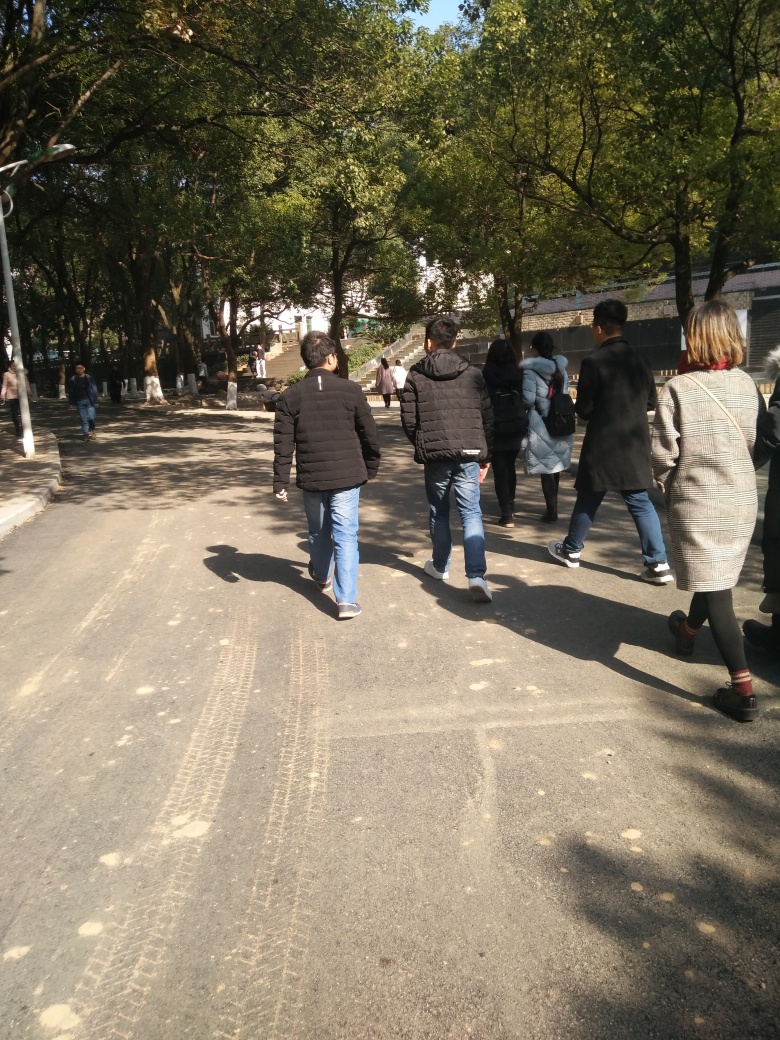Can you describe the atmosphere of the location? The location appears tranquil and usual for a leisurely stroll, with a spacious walkway lined with mature trees providing shade. The presence of multiple pedestrians suggests it is a popular public space. 